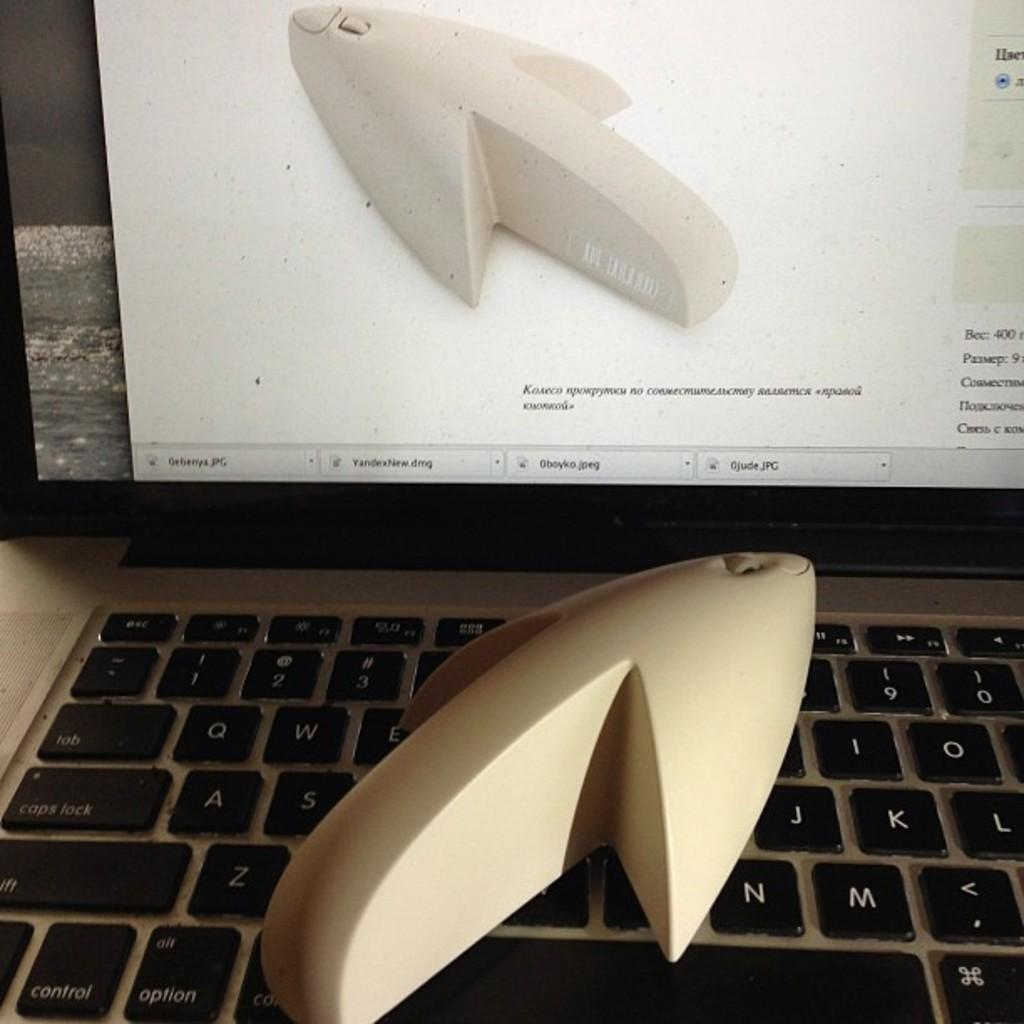<image>
Share a concise interpretation of the image provided. Three .jpg files and a .dmg file are open, one of which shows the same object that is on the keyboard. 